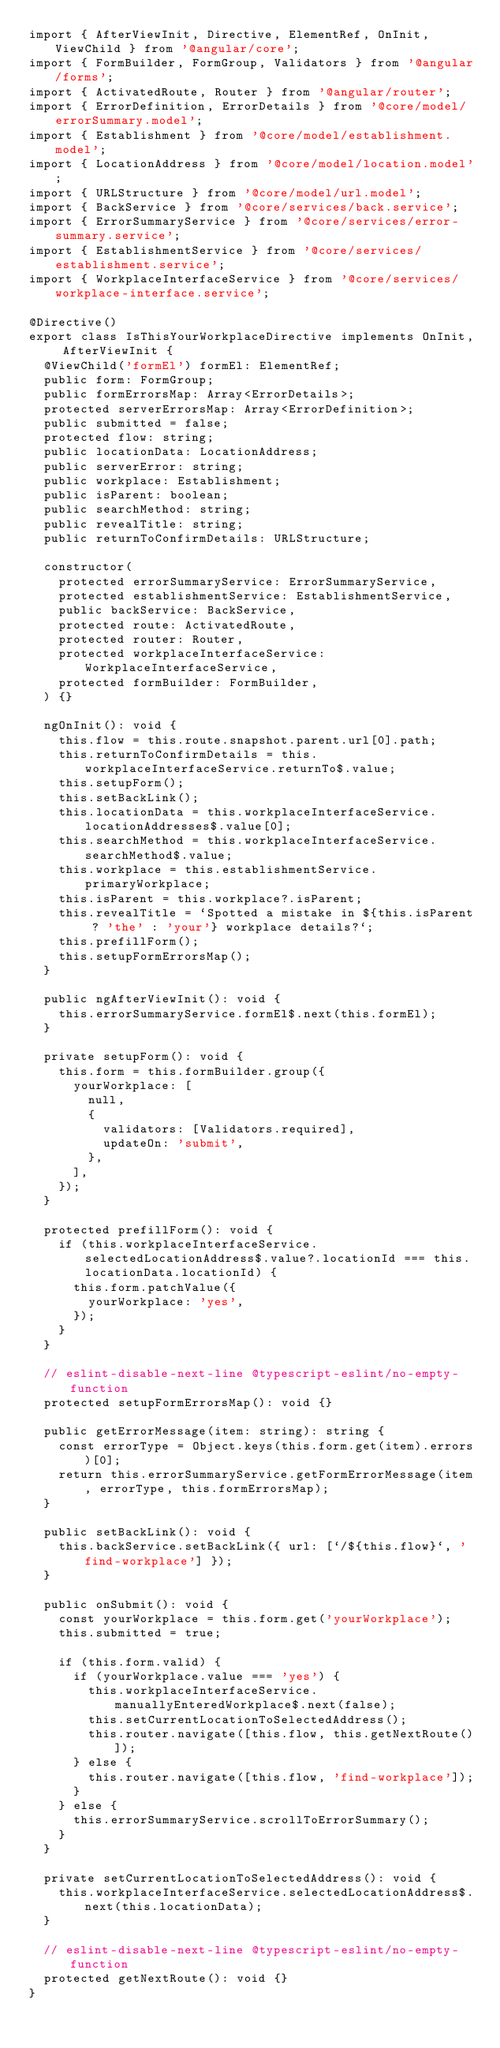<code> <loc_0><loc_0><loc_500><loc_500><_TypeScript_>import { AfterViewInit, Directive, ElementRef, OnInit, ViewChild } from '@angular/core';
import { FormBuilder, FormGroup, Validators } from '@angular/forms';
import { ActivatedRoute, Router } from '@angular/router';
import { ErrorDefinition, ErrorDetails } from '@core/model/errorSummary.model';
import { Establishment } from '@core/model/establishment.model';
import { LocationAddress } from '@core/model/location.model';
import { URLStructure } from '@core/model/url.model';
import { BackService } from '@core/services/back.service';
import { ErrorSummaryService } from '@core/services/error-summary.service';
import { EstablishmentService } from '@core/services/establishment.service';
import { WorkplaceInterfaceService } from '@core/services/workplace-interface.service';

@Directive()
export class IsThisYourWorkplaceDirective implements OnInit, AfterViewInit {
  @ViewChild('formEl') formEl: ElementRef;
  public form: FormGroup;
  public formErrorsMap: Array<ErrorDetails>;
  protected serverErrorsMap: Array<ErrorDefinition>;
  public submitted = false;
  protected flow: string;
  public locationData: LocationAddress;
  public serverError: string;
  public workplace: Establishment;
  public isParent: boolean;
  public searchMethod: string;
  public revealTitle: string;
  public returnToConfirmDetails: URLStructure;

  constructor(
    protected errorSummaryService: ErrorSummaryService,
    protected establishmentService: EstablishmentService,
    public backService: BackService,
    protected route: ActivatedRoute,
    protected router: Router,
    protected workplaceInterfaceService: WorkplaceInterfaceService,
    protected formBuilder: FormBuilder,
  ) {}

  ngOnInit(): void {
    this.flow = this.route.snapshot.parent.url[0].path;
    this.returnToConfirmDetails = this.workplaceInterfaceService.returnTo$.value;
    this.setupForm();
    this.setBackLink();
    this.locationData = this.workplaceInterfaceService.locationAddresses$.value[0];
    this.searchMethod = this.workplaceInterfaceService.searchMethod$.value;
    this.workplace = this.establishmentService.primaryWorkplace;
    this.isParent = this.workplace?.isParent;
    this.revealTitle = `Spotted a mistake in ${this.isParent ? 'the' : 'your'} workplace details?`;
    this.prefillForm();
    this.setupFormErrorsMap();
  }

  public ngAfterViewInit(): void {
    this.errorSummaryService.formEl$.next(this.formEl);
  }

  private setupForm(): void {
    this.form = this.formBuilder.group({
      yourWorkplace: [
        null,
        {
          validators: [Validators.required],
          updateOn: 'submit',
        },
      ],
    });
  }

  protected prefillForm(): void {
    if (this.workplaceInterfaceService.selectedLocationAddress$.value?.locationId === this.locationData.locationId) {
      this.form.patchValue({
        yourWorkplace: 'yes',
      });
    }
  }

  // eslint-disable-next-line @typescript-eslint/no-empty-function
  protected setupFormErrorsMap(): void {}

  public getErrorMessage(item: string): string {
    const errorType = Object.keys(this.form.get(item).errors)[0];
    return this.errorSummaryService.getFormErrorMessage(item, errorType, this.formErrorsMap);
  }

  public setBackLink(): void {
    this.backService.setBackLink({ url: [`/${this.flow}`, 'find-workplace'] });
  }

  public onSubmit(): void {
    const yourWorkplace = this.form.get('yourWorkplace');
    this.submitted = true;

    if (this.form.valid) {
      if (yourWorkplace.value === 'yes') {
        this.workplaceInterfaceService.manuallyEnteredWorkplace$.next(false);
        this.setCurrentLocationToSelectedAddress();
        this.router.navigate([this.flow, this.getNextRoute()]);
      } else {
        this.router.navigate([this.flow, 'find-workplace']);
      }
    } else {
      this.errorSummaryService.scrollToErrorSummary();
    }
  }

  private setCurrentLocationToSelectedAddress(): void {
    this.workplaceInterfaceService.selectedLocationAddress$.next(this.locationData);
  }

  // eslint-disable-next-line @typescript-eslint/no-empty-function
  protected getNextRoute(): void {}
}
</code> 